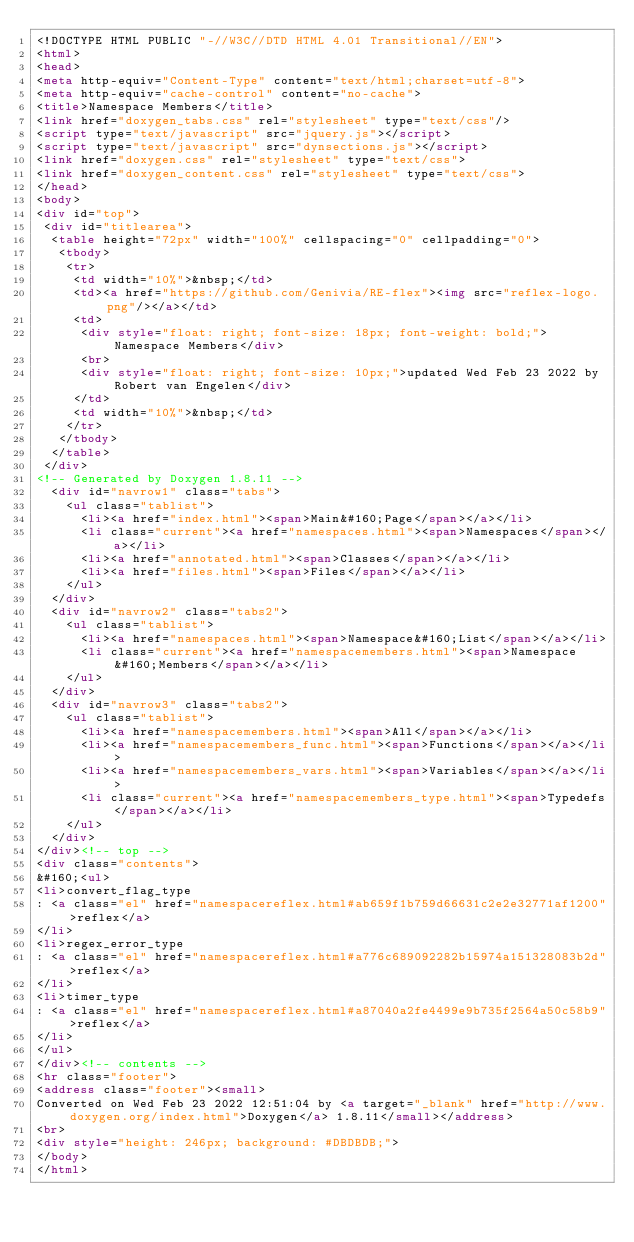Convert code to text. <code><loc_0><loc_0><loc_500><loc_500><_HTML_><!DOCTYPE HTML PUBLIC "-//W3C//DTD HTML 4.01 Transitional//EN">
<html>
<head>
<meta http-equiv="Content-Type" content="text/html;charset=utf-8">
<meta http-equiv="cache-control" content="no-cache">
<title>Namespace Members</title>
<link href="doxygen_tabs.css" rel="stylesheet" type="text/css"/>
<script type="text/javascript" src="jquery.js"></script>
<script type="text/javascript" src="dynsections.js"></script>
<link href="doxygen.css" rel="stylesheet" type="text/css">
<link href="doxygen_content.css" rel="stylesheet" type="text/css">
</head>
<body>
<div id="top">
 <div id="titlearea">
  <table height="72px" width="100%" cellspacing="0" cellpadding="0">
   <tbody>
    <tr>
     <td width="10%">&nbsp;</td>
     <td><a href="https://github.com/Genivia/RE-flex"><img src="reflex-logo.png"/></a></td>
     <td>
      <div style="float: right; font-size: 18px; font-weight: bold;">Namespace Members</div>
      <br>
      <div style="float: right; font-size: 10px;">updated Wed Feb 23 2022 by Robert van Engelen</div>
     </td>
     <td width="10%">&nbsp;</td>
    </tr>
   </tbody>
  </table>
 </div>
<!-- Generated by Doxygen 1.8.11 -->
  <div id="navrow1" class="tabs">
    <ul class="tablist">
      <li><a href="index.html"><span>Main&#160;Page</span></a></li>
      <li class="current"><a href="namespaces.html"><span>Namespaces</span></a></li>
      <li><a href="annotated.html"><span>Classes</span></a></li>
      <li><a href="files.html"><span>Files</span></a></li>
    </ul>
  </div>
  <div id="navrow2" class="tabs2">
    <ul class="tablist">
      <li><a href="namespaces.html"><span>Namespace&#160;List</span></a></li>
      <li class="current"><a href="namespacemembers.html"><span>Namespace&#160;Members</span></a></li>
    </ul>
  </div>
  <div id="navrow3" class="tabs2">
    <ul class="tablist">
      <li><a href="namespacemembers.html"><span>All</span></a></li>
      <li><a href="namespacemembers_func.html"><span>Functions</span></a></li>
      <li><a href="namespacemembers_vars.html"><span>Variables</span></a></li>
      <li class="current"><a href="namespacemembers_type.html"><span>Typedefs</span></a></li>
    </ul>
  </div>
</div><!-- top -->
<div class="contents">
&#160;<ul>
<li>convert_flag_type
: <a class="el" href="namespacereflex.html#ab659f1b759d66631c2e2e32771af1200">reflex</a>
</li>
<li>regex_error_type
: <a class="el" href="namespacereflex.html#a776c689092282b15974a151328083b2d">reflex</a>
</li>
<li>timer_type
: <a class="el" href="namespacereflex.html#a87040a2fe4499e9b735f2564a50c58b9">reflex</a>
</li>
</ul>
</div><!-- contents -->
<hr class="footer">
<address class="footer"><small>
Converted on Wed Feb 23 2022 12:51:04 by <a target="_blank" href="http://www.doxygen.org/index.html">Doxygen</a> 1.8.11</small></address>
<br>
<div style="height: 246px; background: #DBDBDB;">
</body>
</html>
</code> 